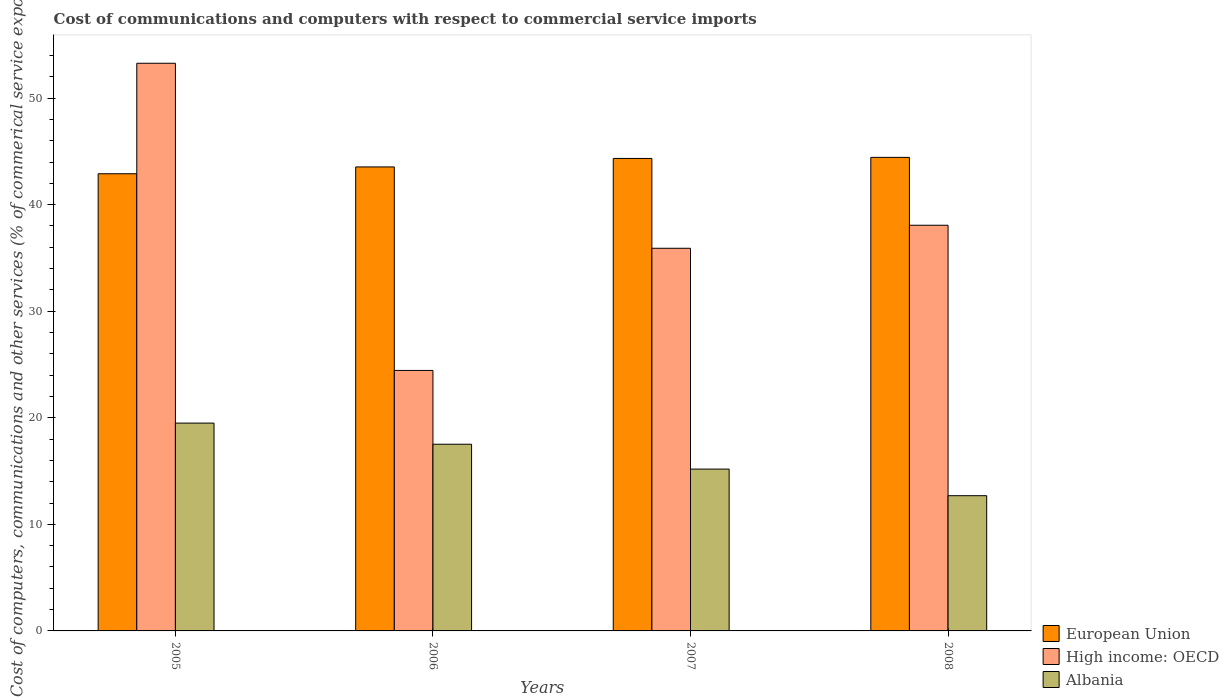How many bars are there on the 4th tick from the left?
Provide a succinct answer. 3. How many bars are there on the 3rd tick from the right?
Give a very brief answer. 3. What is the label of the 3rd group of bars from the left?
Your response must be concise. 2007. In how many cases, is the number of bars for a given year not equal to the number of legend labels?
Offer a terse response. 0. What is the cost of communications and computers in Albania in 2005?
Provide a succinct answer. 19.5. Across all years, what is the maximum cost of communications and computers in Albania?
Make the answer very short. 19.5. Across all years, what is the minimum cost of communications and computers in High income: OECD?
Offer a terse response. 24.45. In which year was the cost of communications and computers in European Union minimum?
Your response must be concise. 2005. What is the total cost of communications and computers in European Union in the graph?
Offer a very short reply. 175.22. What is the difference between the cost of communications and computers in Albania in 2006 and that in 2007?
Give a very brief answer. 2.33. What is the difference between the cost of communications and computers in Albania in 2007 and the cost of communications and computers in High income: OECD in 2005?
Give a very brief answer. -38.08. What is the average cost of communications and computers in High income: OECD per year?
Keep it short and to the point. 37.92. In the year 2007, what is the difference between the cost of communications and computers in Albania and cost of communications and computers in High income: OECD?
Offer a very short reply. -20.72. What is the ratio of the cost of communications and computers in High income: OECD in 2006 to that in 2007?
Provide a succinct answer. 0.68. Is the difference between the cost of communications and computers in Albania in 2007 and 2008 greater than the difference between the cost of communications and computers in High income: OECD in 2007 and 2008?
Offer a very short reply. Yes. What is the difference between the highest and the second highest cost of communications and computers in European Union?
Offer a very short reply. 0.1. What is the difference between the highest and the lowest cost of communications and computers in European Union?
Provide a succinct answer. 1.54. Is the sum of the cost of communications and computers in Albania in 2005 and 2006 greater than the maximum cost of communications and computers in High income: OECD across all years?
Your response must be concise. No. What does the 3rd bar from the left in 2008 represents?
Offer a terse response. Albania. What does the 2nd bar from the right in 2006 represents?
Your response must be concise. High income: OECD. Is it the case that in every year, the sum of the cost of communications and computers in Albania and cost of communications and computers in High income: OECD is greater than the cost of communications and computers in European Union?
Provide a short and direct response. No. Are all the bars in the graph horizontal?
Your answer should be compact. No. What is the difference between two consecutive major ticks on the Y-axis?
Provide a short and direct response. 10. Does the graph contain grids?
Offer a terse response. No. Where does the legend appear in the graph?
Offer a very short reply. Bottom right. How many legend labels are there?
Provide a succinct answer. 3. How are the legend labels stacked?
Keep it short and to the point. Vertical. What is the title of the graph?
Ensure brevity in your answer.  Cost of communications and computers with respect to commercial service imports. What is the label or title of the X-axis?
Ensure brevity in your answer.  Years. What is the label or title of the Y-axis?
Make the answer very short. Cost of computers, communications and other services (% of commerical service exports). What is the Cost of computers, communications and other services (% of commerical service exports) in European Union in 2005?
Provide a short and direct response. 42.9. What is the Cost of computers, communications and other services (% of commerical service exports) of High income: OECD in 2005?
Offer a terse response. 53.27. What is the Cost of computers, communications and other services (% of commerical service exports) in Albania in 2005?
Your answer should be very brief. 19.5. What is the Cost of computers, communications and other services (% of commerical service exports) in European Union in 2006?
Your response must be concise. 43.54. What is the Cost of computers, communications and other services (% of commerical service exports) in High income: OECD in 2006?
Provide a short and direct response. 24.45. What is the Cost of computers, communications and other services (% of commerical service exports) of Albania in 2006?
Give a very brief answer. 17.52. What is the Cost of computers, communications and other services (% of commerical service exports) of European Union in 2007?
Your response must be concise. 44.34. What is the Cost of computers, communications and other services (% of commerical service exports) in High income: OECD in 2007?
Your response must be concise. 35.91. What is the Cost of computers, communications and other services (% of commerical service exports) in Albania in 2007?
Your answer should be compact. 15.19. What is the Cost of computers, communications and other services (% of commerical service exports) of European Union in 2008?
Make the answer very short. 44.44. What is the Cost of computers, communications and other services (% of commerical service exports) in High income: OECD in 2008?
Ensure brevity in your answer.  38.07. What is the Cost of computers, communications and other services (% of commerical service exports) in Albania in 2008?
Your response must be concise. 12.69. Across all years, what is the maximum Cost of computers, communications and other services (% of commerical service exports) in European Union?
Your response must be concise. 44.44. Across all years, what is the maximum Cost of computers, communications and other services (% of commerical service exports) in High income: OECD?
Keep it short and to the point. 53.27. Across all years, what is the maximum Cost of computers, communications and other services (% of commerical service exports) in Albania?
Keep it short and to the point. 19.5. Across all years, what is the minimum Cost of computers, communications and other services (% of commerical service exports) in European Union?
Give a very brief answer. 42.9. Across all years, what is the minimum Cost of computers, communications and other services (% of commerical service exports) of High income: OECD?
Keep it short and to the point. 24.45. Across all years, what is the minimum Cost of computers, communications and other services (% of commerical service exports) of Albania?
Your response must be concise. 12.69. What is the total Cost of computers, communications and other services (% of commerical service exports) of European Union in the graph?
Your answer should be very brief. 175.22. What is the total Cost of computers, communications and other services (% of commerical service exports) of High income: OECD in the graph?
Your response must be concise. 151.7. What is the total Cost of computers, communications and other services (% of commerical service exports) in Albania in the graph?
Your answer should be compact. 64.9. What is the difference between the Cost of computers, communications and other services (% of commerical service exports) in European Union in 2005 and that in 2006?
Offer a very short reply. -0.64. What is the difference between the Cost of computers, communications and other services (% of commerical service exports) of High income: OECD in 2005 and that in 2006?
Your answer should be compact. 28.83. What is the difference between the Cost of computers, communications and other services (% of commerical service exports) of Albania in 2005 and that in 2006?
Offer a very short reply. 1.98. What is the difference between the Cost of computers, communications and other services (% of commerical service exports) of European Union in 2005 and that in 2007?
Provide a succinct answer. -1.44. What is the difference between the Cost of computers, communications and other services (% of commerical service exports) in High income: OECD in 2005 and that in 2007?
Offer a very short reply. 17.36. What is the difference between the Cost of computers, communications and other services (% of commerical service exports) of Albania in 2005 and that in 2007?
Make the answer very short. 4.32. What is the difference between the Cost of computers, communications and other services (% of commerical service exports) of European Union in 2005 and that in 2008?
Ensure brevity in your answer.  -1.54. What is the difference between the Cost of computers, communications and other services (% of commerical service exports) in High income: OECD in 2005 and that in 2008?
Provide a succinct answer. 15.2. What is the difference between the Cost of computers, communications and other services (% of commerical service exports) of Albania in 2005 and that in 2008?
Your answer should be very brief. 6.81. What is the difference between the Cost of computers, communications and other services (% of commerical service exports) of European Union in 2006 and that in 2007?
Keep it short and to the point. -0.8. What is the difference between the Cost of computers, communications and other services (% of commerical service exports) in High income: OECD in 2006 and that in 2007?
Keep it short and to the point. -11.46. What is the difference between the Cost of computers, communications and other services (% of commerical service exports) in Albania in 2006 and that in 2007?
Make the answer very short. 2.33. What is the difference between the Cost of computers, communications and other services (% of commerical service exports) in European Union in 2006 and that in 2008?
Ensure brevity in your answer.  -0.9. What is the difference between the Cost of computers, communications and other services (% of commerical service exports) of High income: OECD in 2006 and that in 2008?
Make the answer very short. -13.62. What is the difference between the Cost of computers, communications and other services (% of commerical service exports) in Albania in 2006 and that in 2008?
Provide a short and direct response. 4.83. What is the difference between the Cost of computers, communications and other services (% of commerical service exports) of European Union in 2007 and that in 2008?
Your answer should be very brief. -0.1. What is the difference between the Cost of computers, communications and other services (% of commerical service exports) of High income: OECD in 2007 and that in 2008?
Offer a terse response. -2.16. What is the difference between the Cost of computers, communications and other services (% of commerical service exports) of Albania in 2007 and that in 2008?
Offer a very short reply. 2.5. What is the difference between the Cost of computers, communications and other services (% of commerical service exports) of European Union in 2005 and the Cost of computers, communications and other services (% of commerical service exports) of High income: OECD in 2006?
Your answer should be very brief. 18.46. What is the difference between the Cost of computers, communications and other services (% of commerical service exports) in European Union in 2005 and the Cost of computers, communications and other services (% of commerical service exports) in Albania in 2006?
Make the answer very short. 25.38. What is the difference between the Cost of computers, communications and other services (% of commerical service exports) in High income: OECD in 2005 and the Cost of computers, communications and other services (% of commerical service exports) in Albania in 2006?
Keep it short and to the point. 35.75. What is the difference between the Cost of computers, communications and other services (% of commerical service exports) in European Union in 2005 and the Cost of computers, communications and other services (% of commerical service exports) in High income: OECD in 2007?
Give a very brief answer. 6.99. What is the difference between the Cost of computers, communications and other services (% of commerical service exports) of European Union in 2005 and the Cost of computers, communications and other services (% of commerical service exports) of Albania in 2007?
Your response must be concise. 27.71. What is the difference between the Cost of computers, communications and other services (% of commerical service exports) in High income: OECD in 2005 and the Cost of computers, communications and other services (% of commerical service exports) in Albania in 2007?
Keep it short and to the point. 38.08. What is the difference between the Cost of computers, communications and other services (% of commerical service exports) in European Union in 2005 and the Cost of computers, communications and other services (% of commerical service exports) in High income: OECD in 2008?
Ensure brevity in your answer.  4.83. What is the difference between the Cost of computers, communications and other services (% of commerical service exports) of European Union in 2005 and the Cost of computers, communications and other services (% of commerical service exports) of Albania in 2008?
Ensure brevity in your answer.  30.21. What is the difference between the Cost of computers, communications and other services (% of commerical service exports) of High income: OECD in 2005 and the Cost of computers, communications and other services (% of commerical service exports) of Albania in 2008?
Your answer should be very brief. 40.58. What is the difference between the Cost of computers, communications and other services (% of commerical service exports) of European Union in 2006 and the Cost of computers, communications and other services (% of commerical service exports) of High income: OECD in 2007?
Provide a succinct answer. 7.63. What is the difference between the Cost of computers, communications and other services (% of commerical service exports) in European Union in 2006 and the Cost of computers, communications and other services (% of commerical service exports) in Albania in 2007?
Your response must be concise. 28.36. What is the difference between the Cost of computers, communications and other services (% of commerical service exports) of High income: OECD in 2006 and the Cost of computers, communications and other services (% of commerical service exports) of Albania in 2007?
Make the answer very short. 9.26. What is the difference between the Cost of computers, communications and other services (% of commerical service exports) in European Union in 2006 and the Cost of computers, communications and other services (% of commerical service exports) in High income: OECD in 2008?
Keep it short and to the point. 5.47. What is the difference between the Cost of computers, communications and other services (% of commerical service exports) of European Union in 2006 and the Cost of computers, communications and other services (% of commerical service exports) of Albania in 2008?
Provide a short and direct response. 30.85. What is the difference between the Cost of computers, communications and other services (% of commerical service exports) in High income: OECD in 2006 and the Cost of computers, communications and other services (% of commerical service exports) in Albania in 2008?
Provide a succinct answer. 11.76. What is the difference between the Cost of computers, communications and other services (% of commerical service exports) of European Union in 2007 and the Cost of computers, communications and other services (% of commerical service exports) of High income: OECD in 2008?
Provide a short and direct response. 6.27. What is the difference between the Cost of computers, communications and other services (% of commerical service exports) in European Union in 2007 and the Cost of computers, communications and other services (% of commerical service exports) in Albania in 2008?
Give a very brief answer. 31.65. What is the difference between the Cost of computers, communications and other services (% of commerical service exports) of High income: OECD in 2007 and the Cost of computers, communications and other services (% of commerical service exports) of Albania in 2008?
Your answer should be very brief. 23.22. What is the average Cost of computers, communications and other services (% of commerical service exports) of European Union per year?
Ensure brevity in your answer.  43.81. What is the average Cost of computers, communications and other services (% of commerical service exports) of High income: OECD per year?
Offer a terse response. 37.92. What is the average Cost of computers, communications and other services (% of commerical service exports) of Albania per year?
Give a very brief answer. 16.22. In the year 2005, what is the difference between the Cost of computers, communications and other services (% of commerical service exports) in European Union and Cost of computers, communications and other services (% of commerical service exports) in High income: OECD?
Give a very brief answer. -10.37. In the year 2005, what is the difference between the Cost of computers, communications and other services (% of commerical service exports) in European Union and Cost of computers, communications and other services (% of commerical service exports) in Albania?
Offer a terse response. 23.4. In the year 2005, what is the difference between the Cost of computers, communications and other services (% of commerical service exports) of High income: OECD and Cost of computers, communications and other services (% of commerical service exports) of Albania?
Your answer should be compact. 33.77. In the year 2006, what is the difference between the Cost of computers, communications and other services (% of commerical service exports) in European Union and Cost of computers, communications and other services (% of commerical service exports) in High income: OECD?
Offer a terse response. 19.1. In the year 2006, what is the difference between the Cost of computers, communications and other services (% of commerical service exports) in European Union and Cost of computers, communications and other services (% of commerical service exports) in Albania?
Your answer should be compact. 26.02. In the year 2006, what is the difference between the Cost of computers, communications and other services (% of commerical service exports) in High income: OECD and Cost of computers, communications and other services (% of commerical service exports) in Albania?
Your response must be concise. 6.93. In the year 2007, what is the difference between the Cost of computers, communications and other services (% of commerical service exports) of European Union and Cost of computers, communications and other services (% of commerical service exports) of High income: OECD?
Offer a very short reply. 8.43. In the year 2007, what is the difference between the Cost of computers, communications and other services (% of commerical service exports) in European Union and Cost of computers, communications and other services (% of commerical service exports) in Albania?
Your answer should be very brief. 29.15. In the year 2007, what is the difference between the Cost of computers, communications and other services (% of commerical service exports) of High income: OECD and Cost of computers, communications and other services (% of commerical service exports) of Albania?
Provide a short and direct response. 20.72. In the year 2008, what is the difference between the Cost of computers, communications and other services (% of commerical service exports) in European Union and Cost of computers, communications and other services (% of commerical service exports) in High income: OECD?
Make the answer very short. 6.37. In the year 2008, what is the difference between the Cost of computers, communications and other services (% of commerical service exports) of European Union and Cost of computers, communications and other services (% of commerical service exports) of Albania?
Keep it short and to the point. 31.75. In the year 2008, what is the difference between the Cost of computers, communications and other services (% of commerical service exports) of High income: OECD and Cost of computers, communications and other services (% of commerical service exports) of Albania?
Provide a succinct answer. 25.38. What is the ratio of the Cost of computers, communications and other services (% of commerical service exports) in European Union in 2005 to that in 2006?
Ensure brevity in your answer.  0.99. What is the ratio of the Cost of computers, communications and other services (% of commerical service exports) of High income: OECD in 2005 to that in 2006?
Provide a succinct answer. 2.18. What is the ratio of the Cost of computers, communications and other services (% of commerical service exports) in Albania in 2005 to that in 2006?
Make the answer very short. 1.11. What is the ratio of the Cost of computers, communications and other services (% of commerical service exports) in European Union in 2005 to that in 2007?
Your response must be concise. 0.97. What is the ratio of the Cost of computers, communications and other services (% of commerical service exports) of High income: OECD in 2005 to that in 2007?
Provide a succinct answer. 1.48. What is the ratio of the Cost of computers, communications and other services (% of commerical service exports) of Albania in 2005 to that in 2007?
Keep it short and to the point. 1.28. What is the ratio of the Cost of computers, communications and other services (% of commerical service exports) in European Union in 2005 to that in 2008?
Provide a succinct answer. 0.97. What is the ratio of the Cost of computers, communications and other services (% of commerical service exports) of High income: OECD in 2005 to that in 2008?
Provide a succinct answer. 1.4. What is the ratio of the Cost of computers, communications and other services (% of commerical service exports) of Albania in 2005 to that in 2008?
Offer a terse response. 1.54. What is the ratio of the Cost of computers, communications and other services (% of commerical service exports) in European Union in 2006 to that in 2007?
Provide a short and direct response. 0.98. What is the ratio of the Cost of computers, communications and other services (% of commerical service exports) in High income: OECD in 2006 to that in 2007?
Ensure brevity in your answer.  0.68. What is the ratio of the Cost of computers, communications and other services (% of commerical service exports) in Albania in 2006 to that in 2007?
Provide a succinct answer. 1.15. What is the ratio of the Cost of computers, communications and other services (% of commerical service exports) of European Union in 2006 to that in 2008?
Offer a very short reply. 0.98. What is the ratio of the Cost of computers, communications and other services (% of commerical service exports) in High income: OECD in 2006 to that in 2008?
Your answer should be very brief. 0.64. What is the ratio of the Cost of computers, communications and other services (% of commerical service exports) in Albania in 2006 to that in 2008?
Offer a very short reply. 1.38. What is the ratio of the Cost of computers, communications and other services (% of commerical service exports) of European Union in 2007 to that in 2008?
Provide a succinct answer. 1. What is the ratio of the Cost of computers, communications and other services (% of commerical service exports) in High income: OECD in 2007 to that in 2008?
Your answer should be compact. 0.94. What is the ratio of the Cost of computers, communications and other services (% of commerical service exports) in Albania in 2007 to that in 2008?
Your response must be concise. 1.2. What is the difference between the highest and the second highest Cost of computers, communications and other services (% of commerical service exports) in European Union?
Your answer should be compact. 0.1. What is the difference between the highest and the second highest Cost of computers, communications and other services (% of commerical service exports) of High income: OECD?
Keep it short and to the point. 15.2. What is the difference between the highest and the second highest Cost of computers, communications and other services (% of commerical service exports) of Albania?
Offer a terse response. 1.98. What is the difference between the highest and the lowest Cost of computers, communications and other services (% of commerical service exports) in European Union?
Your answer should be very brief. 1.54. What is the difference between the highest and the lowest Cost of computers, communications and other services (% of commerical service exports) of High income: OECD?
Your answer should be compact. 28.83. What is the difference between the highest and the lowest Cost of computers, communications and other services (% of commerical service exports) of Albania?
Your answer should be compact. 6.81. 